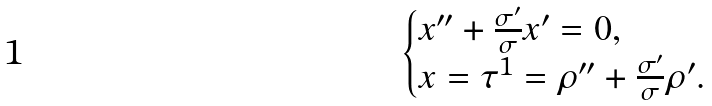<formula> <loc_0><loc_0><loc_500><loc_500>\begin{cases} x ^ { \prime \prime } + \frac { \sigma ^ { \prime } } { \sigma } x ^ { \prime } = 0 , \\ x = \tau ^ { 1 } = \rho ^ { \prime \prime } + \frac { \sigma ^ { \prime } } { \sigma } \rho ^ { \prime } . \end{cases}</formula> 